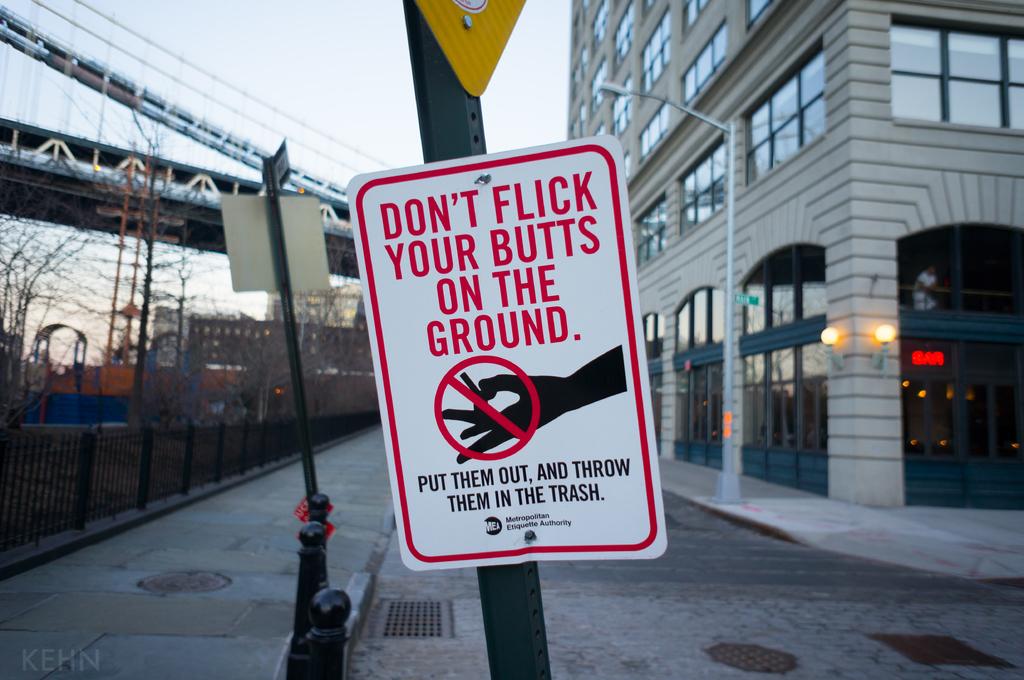Where shouldn't you flick your butts?
Your answer should be very brief. On the ground. 